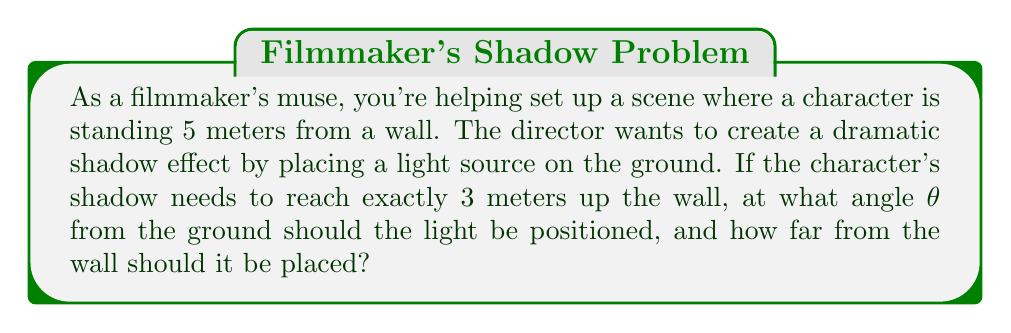Solve this math problem. Let's approach this step-by-step using trigonometry:

1) First, let's visualize the scenario:

[asy]
import geometry;

size(200);
defaultpen(fontsize(10pt));

pair A = (0,0), B = (8,0), C = (8,3), D = (5,0);
draw(A--B--C--cycle);
draw(D--(5,3),dashed);
label("Wall", (8,1.5), E);
label("Ground", (4,0), S);
label("5m", (2.5,0), N);
label("3m", (8.5,1.5), E);
label("Light", A, SW);
label("Person", D, S);
label("θ", (0.5,0.3), NE);

dot(A);
dot(D);
[/asy]

2) We can see that this forms a right-angled triangle. We know:
   - The adjacent side (distance from light to person) = 5 meters
   - The opposite side (height of shadow on wall) = 3 meters

3) We need to find:
   - The angle θ
   - The hypotenuse (distance from light to wall)

4) To find the angle θ, we can use the tangent function:

   $$\tan θ = \frac{\text{opposite}}{\text{adjacent}} = \frac{3}{5}$$

5) To solve for θ:

   $$θ = \arctan(\frac{3}{5})$$

6) Using a calculator or trigonometric tables, we get:

   $$θ ≈ 30.96°$$

7) To find the distance from the light to the wall, we can use the Pythagorean theorem:

   $$\text{distance}^2 = 5^2 + 3^2 = 25 + 9 = 34$$

8) Taking the square root:

   $$\text{distance} = \sqrt{34} ≈ 5.83 \text{ meters}$$
Answer: $θ ≈ 30.96°$, distance ≈ 5.83 meters 